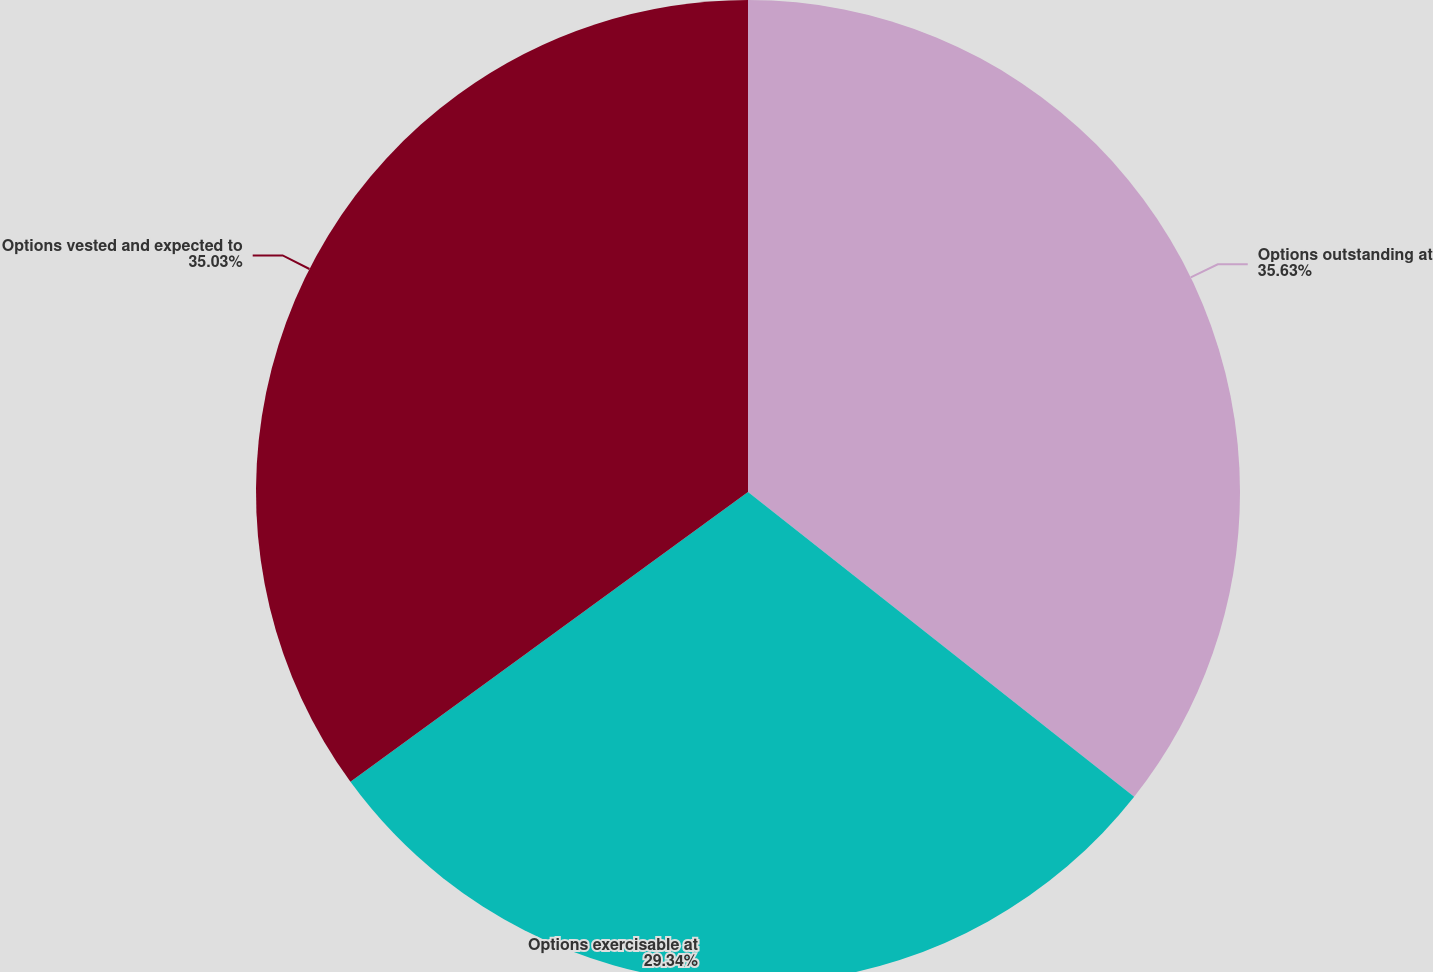Convert chart to OTSL. <chart><loc_0><loc_0><loc_500><loc_500><pie_chart><fcel>Options outstanding at<fcel>Options exercisable at<fcel>Options vested and expected to<nl><fcel>35.64%<fcel>29.34%<fcel>35.03%<nl></chart> 